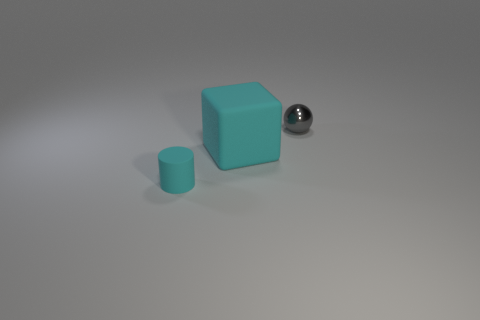There is a big cyan thing that is made of the same material as the tiny cyan object; what is its shape?
Provide a short and direct response. Cube. Are there more large yellow rubber blocks than big objects?
Provide a short and direct response. No. There is a small cyan rubber object; is its shape the same as the matte thing behind the matte cylinder?
Keep it short and to the point. No. What is the big cyan cube made of?
Ensure brevity in your answer.  Rubber. There is a small object that is right of the cyan object that is in front of the cyan rubber object that is to the right of the small cyan rubber cylinder; what color is it?
Ensure brevity in your answer.  Gray. What number of matte cylinders are the same size as the ball?
Your answer should be very brief. 1. How many large matte objects are there?
Offer a terse response. 1. Is the cube made of the same material as the tiny thing behind the small cyan matte object?
Ensure brevity in your answer.  No. How many cyan things are matte cubes or small cylinders?
Offer a terse response. 2. What size is the cylinder that is the same material as the cube?
Your answer should be compact. Small. 